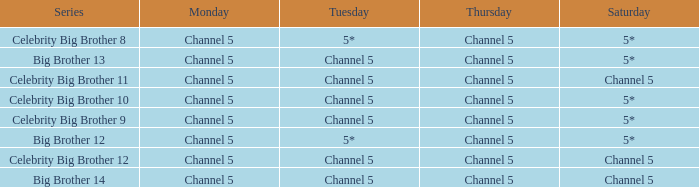Which Thursday does big brother 13 air? Channel 5. 